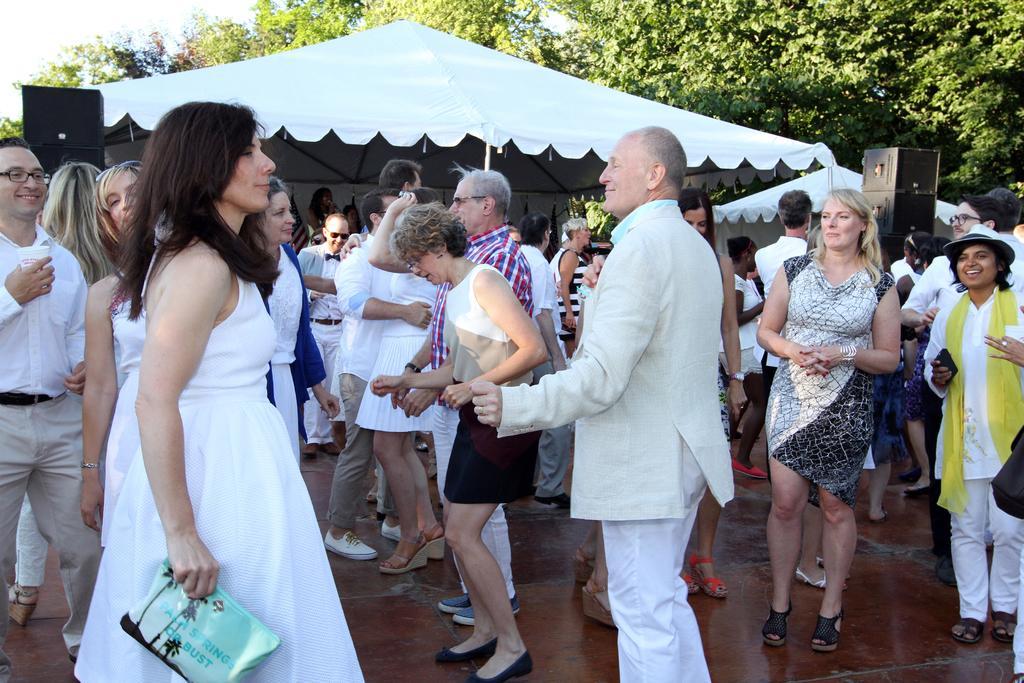Describe this image in one or two sentences. In this image, I can see a group of people standing on the floor. In the background, I can see the canopy tents, speakers, trees and there is the sky. 